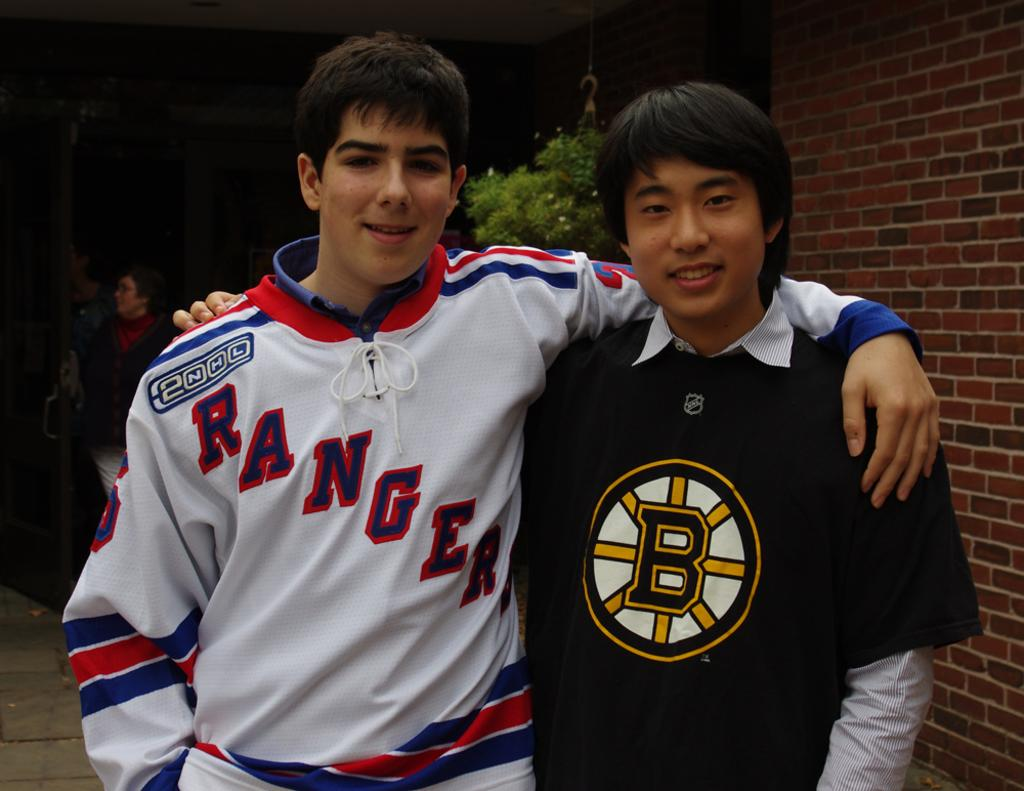<image>
Describe the image concisely. Two young men standing together, one of whom is wearing a shirt with the word Ranger on it. 